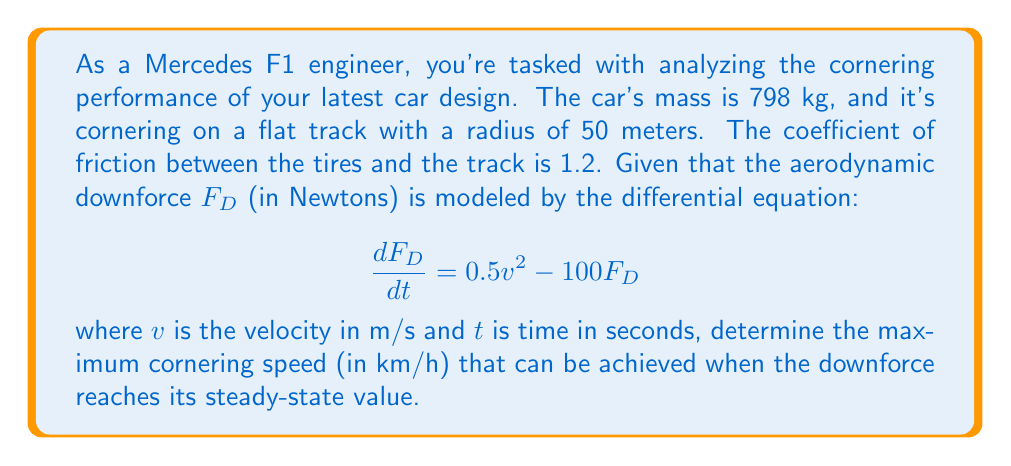Solve this math problem. Let's approach this problem step-by-step:

1) First, we need to find the steady-state value of the downforce. At steady-state, $\frac{dF_D}{dt} = 0$. So:

   $$0 = 0.5v^2 - 100F_D$$
   $$F_D = \frac{0.5v^2}{100} = 0.005v^2$$

2) Now, let's consider the forces acting on the car during cornering. We have the centripetal force, friction force, and the normal force (which includes both the weight of the car and the downforce).

3) The maximum cornering speed occurs when the friction force is at its maximum. The friction force is given by:

   $$F_f = \mu(mg + F_D)$$

   where $\mu$ is the coefficient of friction, $m$ is the mass, and $g$ is the acceleration due to gravity (9.8 m/s²).

4) The centripetal force required for cornering is:

   $$F_c = \frac{mv^2}{r}$$

   where $r$ is the radius of the turn.

5) At the maximum cornering speed, these forces are equal:

   $$\frac{mv^2}{r} = \mu(mg + F_D)$$

6) Substituting the steady-state downforce:

   $$\frac{mv^2}{r} = \mu(mg + 0.005v^2)$$

7) Now let's substitute the known values:

   $$\frac{798v^2}{50} = 1.2(798 \cdot 9.8 + 0.005v^2)$$

8) Simplifying:

   $$15.96v^2 = 9384.48 + 0.006v^2$$
   $$15.954v^2 = 9384.48$$
   $$v^2 = 588.22$$
   $$v = 24.25 \text{ m/s}$$

9) Converting to km/h:

   $$24.25 \frac{\text{m}}{\text{s}} \cdot \frac{3600 \text{ s}}{1 \text{ h}} \cdot \frac{1 \text{ km}}{1000 \text{ m}} = 87.3 \text{ km/h}$$
Answer: The maximum cornering speed is approximately 87.3 km/h. 